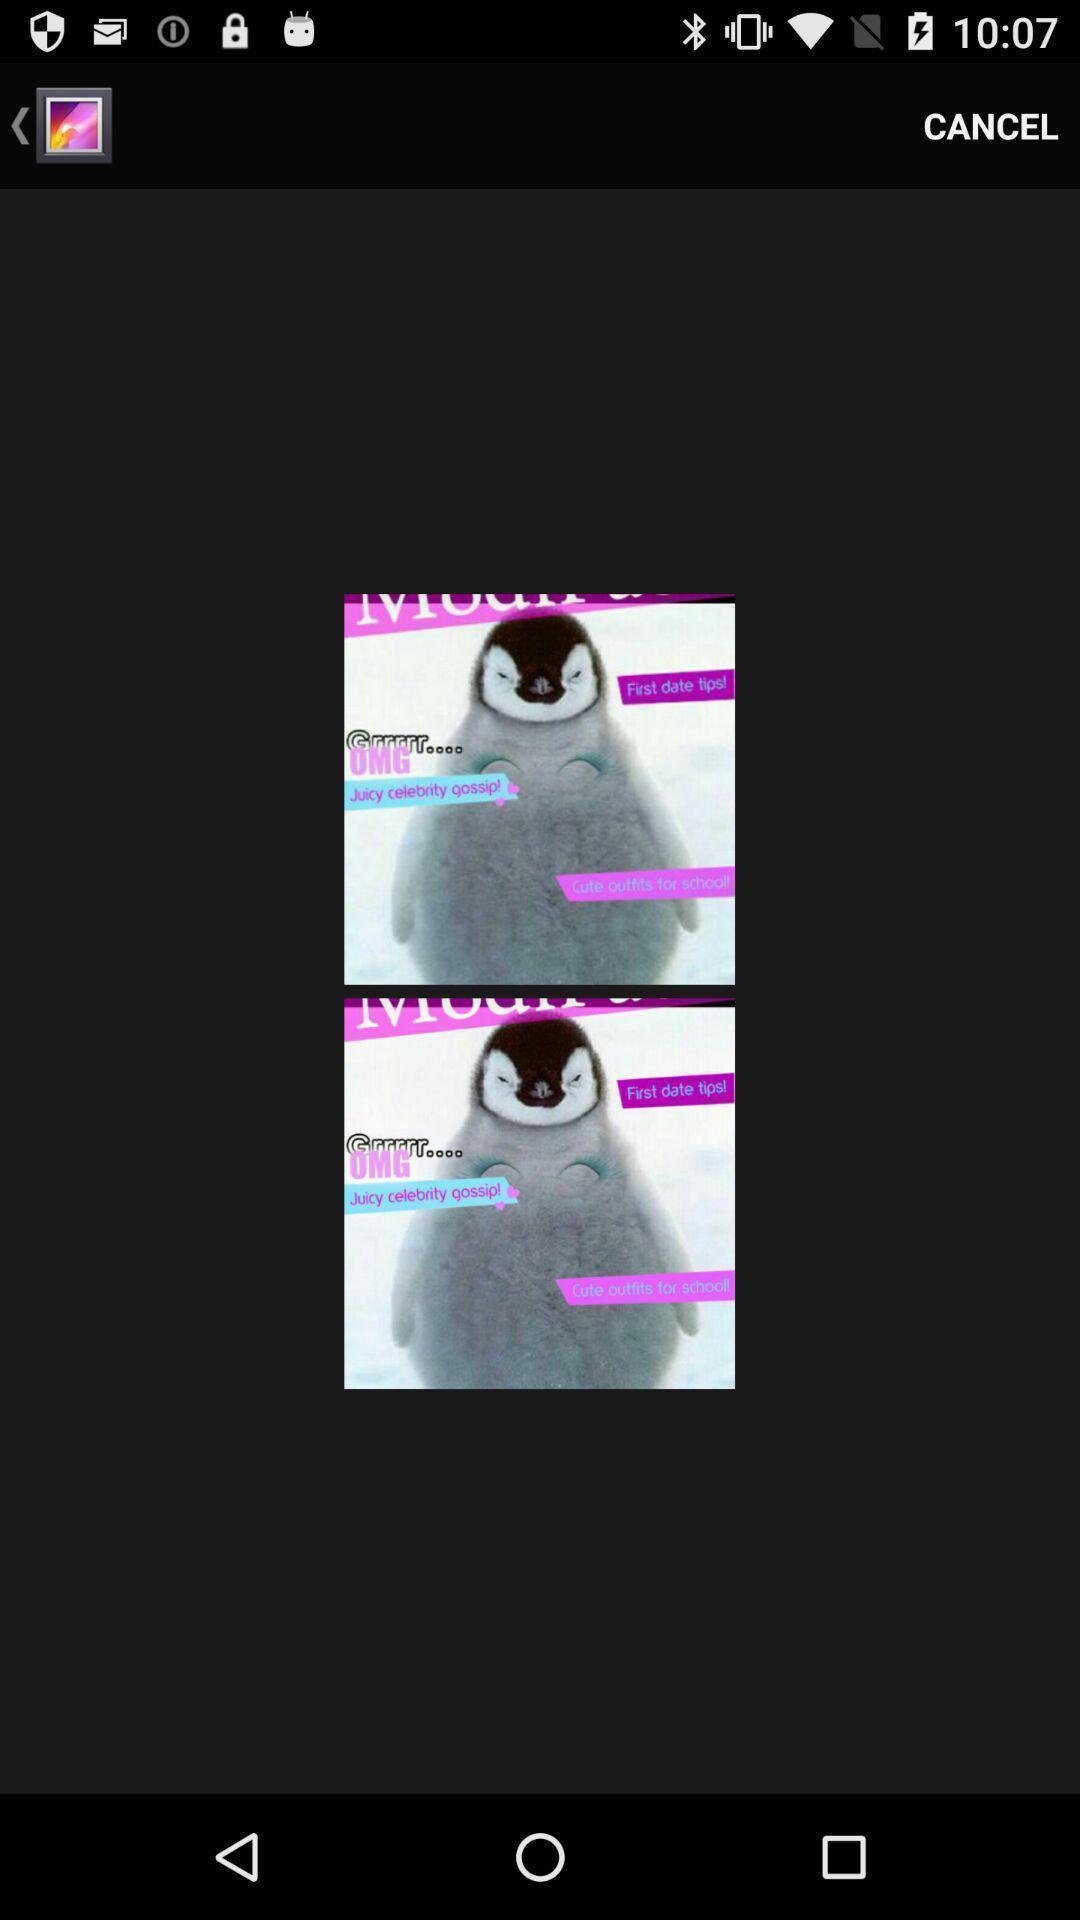Tell me what you see in this picture. Page is showing two similar images in the gallery app. 